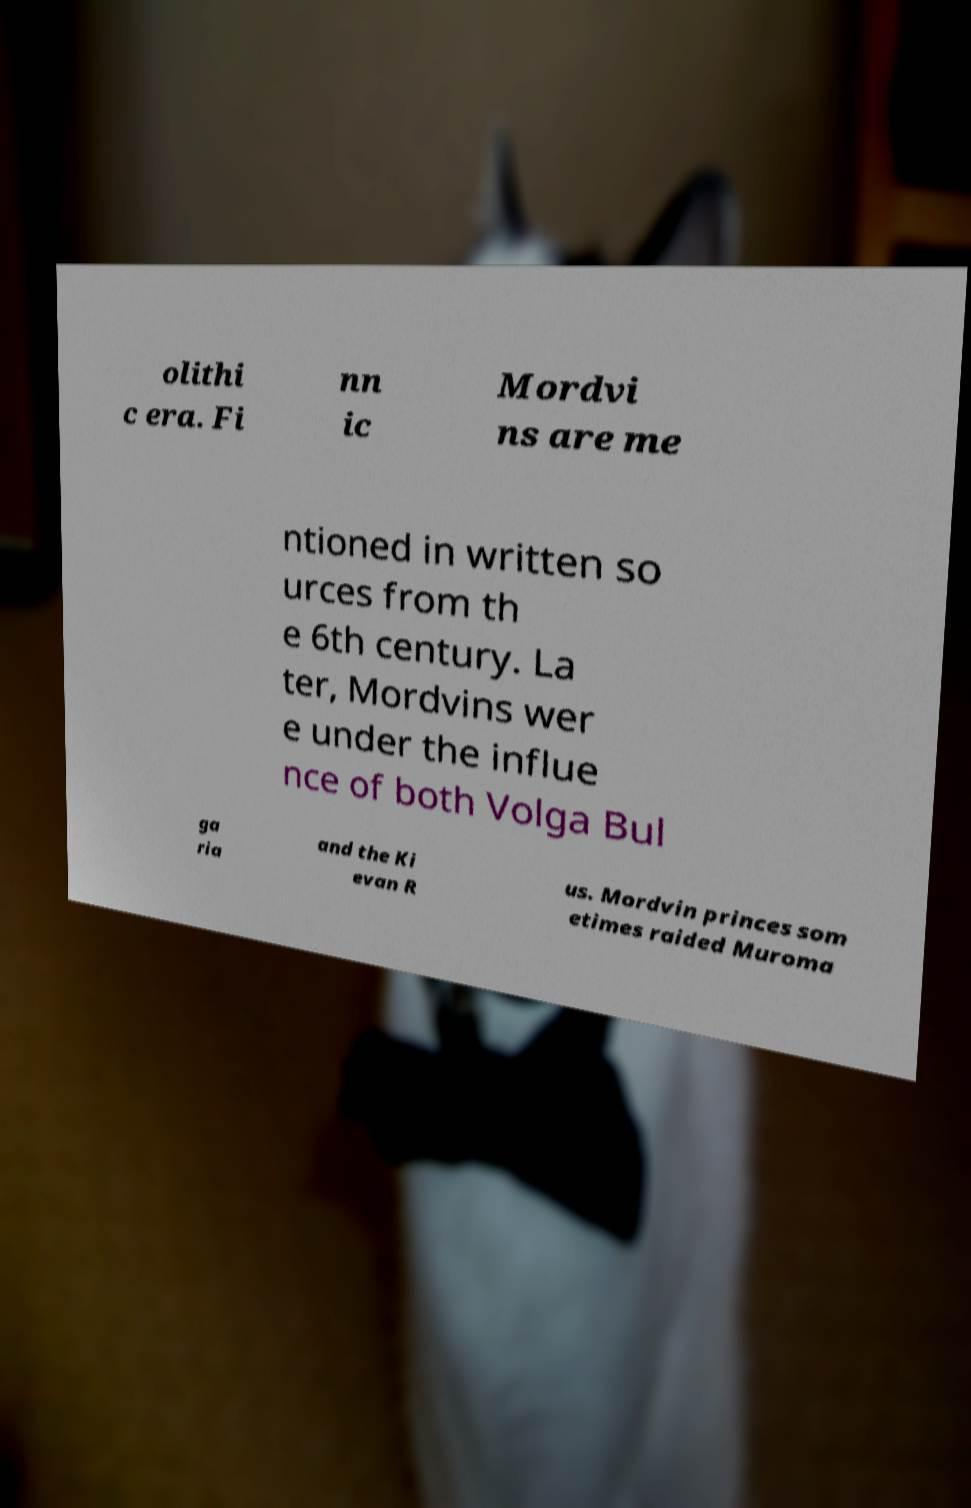For documentation purposes, I need the text within this image transcribed. Could you provide that? olithi c era. Fi nn ic Mordvi ns are me ntioned in written so urces from th e 6th century. La ter, Mordvins wer e under the influe nce of both Volga Bul ga ria and the Ki evan R us. Mordvin princes som etimes raided Muroma 